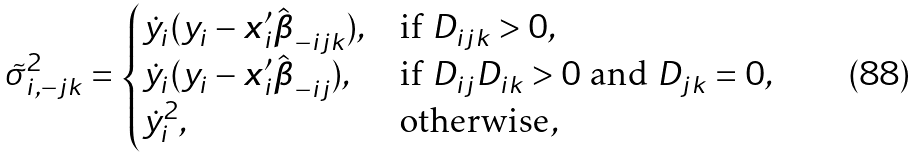<formula> <loc_0><loc_0><loc_500><loc_500>\tilde { \sigma } _ { i , - j k } ^ { 2 } = \begin{cases} \dot { y } _ { i } ( y _ { i } - { \boldsymbol x } _ { i } ^ { \prime } \hat { \boldsymbol \beta } _ { - i j k } ) , & \text {if } D _ { i j k } > 0 , \\ \dot { y } _ { i } ( y _ { i } - { \boldsymbol x } _ { i } ^ { \prime } \hat { \boldsymbol \beta } _ { - i j } ) , & \text {if } D _ { i j } D _ { i k } > 0 \text { and } D _ { j k } = 0 , \\ \dot { y } _ { i } ^ { 2 } , & \text {otherwise} , \end{cases}</formula> 